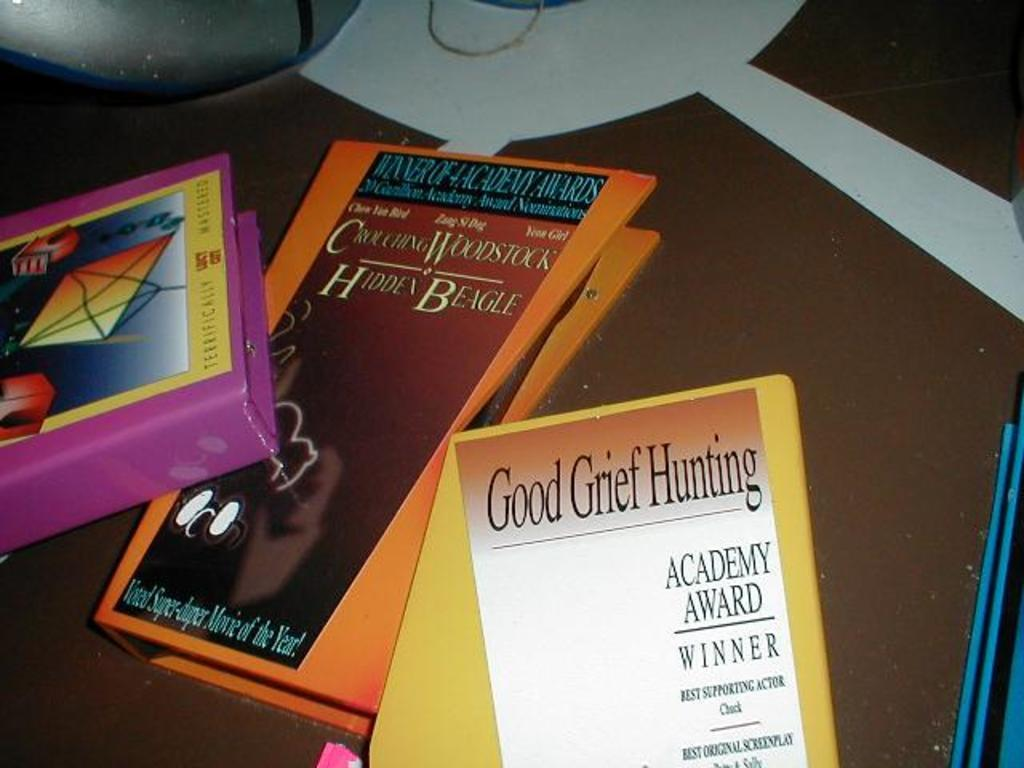<image>
Provide a brief description of the given image. A book titled "Good Grief Hunting" that was an academy award winner. 